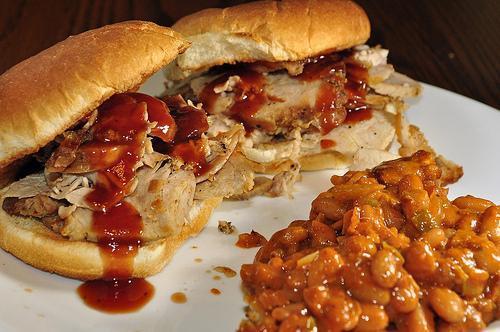How many sandwiches are there?
Give a very brief answer. 2. 